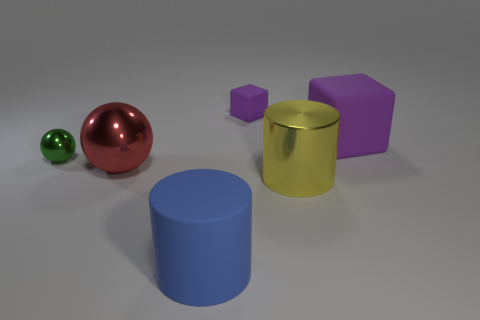What number of other things are there of the same shape as the blue object?
Keep it short and to the point. 1. What is the color of the tiny object on the right side of the tiny green metallic thing to the left of the big shiny object that is on the right side of the red metal sphere?
Give a very brief answer. Purple. How many small things are there?
Your answer should be very brief. 2. What number of large objects are purple metal things or yellow metal cylinders?
Keep it short and to the point. 1. There is a yellow object that is the same size as the rubber cylinder; what shape is it?
Ensure brevity in your answer.  Cylinder. Are there any other things that are the same size as the yellow shiny thing?
Give a very brief answer. Yes. There is a tiny object on the right side of the sphere to the right of the green shiny object; what is its material?
Offer a very short reply. Rubber. Do the blue cylinder and the shiny cylinder have the same size?
Give a very brief answer. Yes. What number of objects are small things right of the small green ball or small purple matte cubes?
Your answer should be compact. 1. There is a small object in front of the purple matte object that is in front of the small purple object; what is its shape?
Keep it short and to the point. Sphere. 